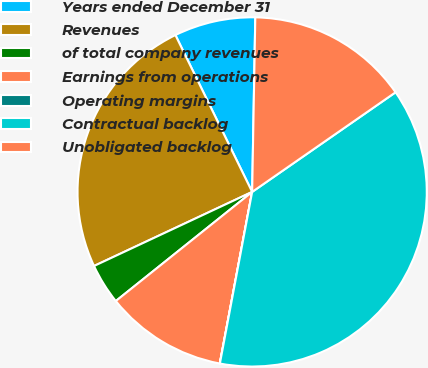Convert chart to OTSL. <chart><loc_0><loc_0><loc_500><loc_500><pie_chart><fcel>Years ended December 31<fcel>Revenues<fcel>of total company revenues<fcel>Earnings from operations<fcel>Operating margins<fcel>Contractual backlog<fcel>Unobligated backlog<nl><fcel>7.53%<fcel>24.73%<fcel>3.77%<fcel>11.29%<fcel>0.01%<fcel>37.62%<fcel>15.05%<nl></chart> 